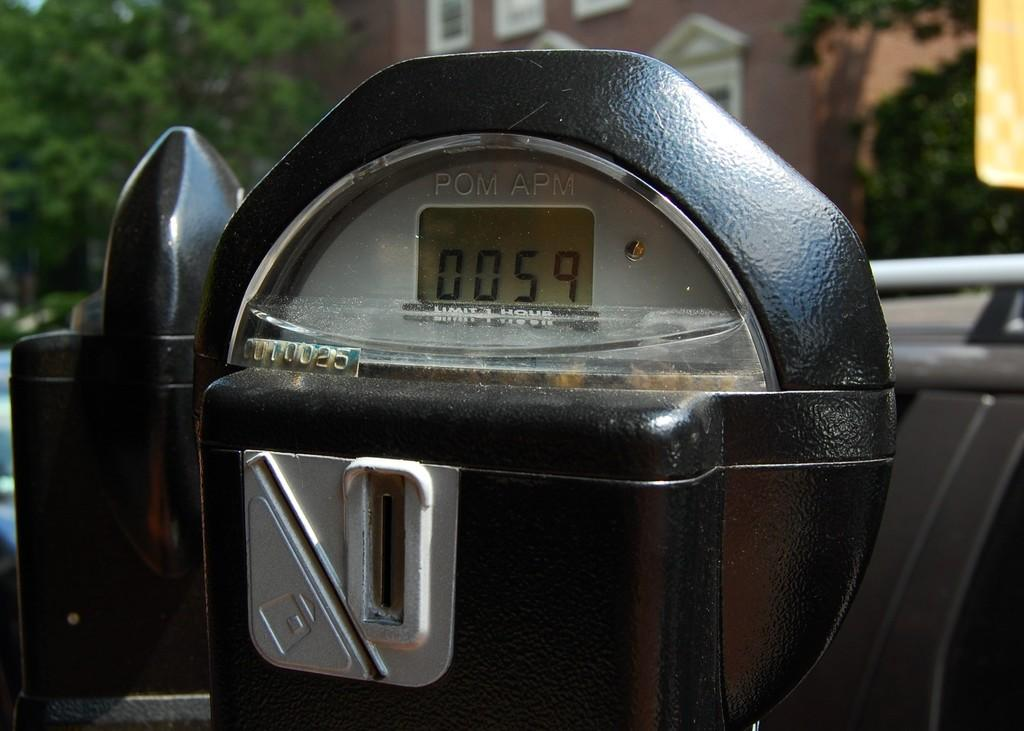<image>
Share a concise interpretation of the image provided. A black parking meter with "POM APM" etched on the front. 